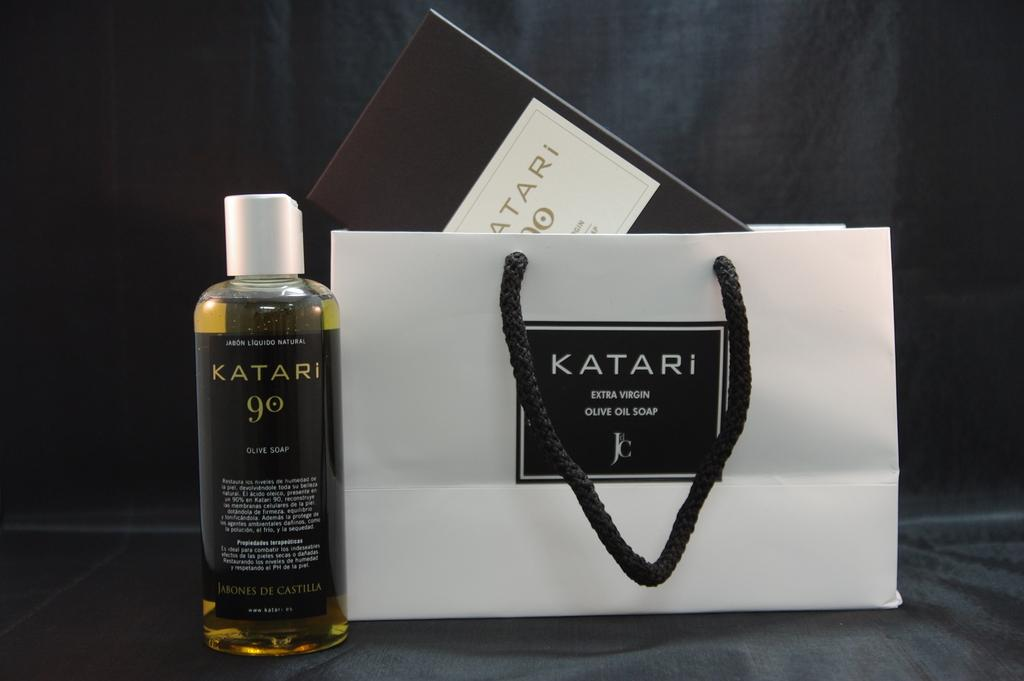Provide a one-sentence caption for the provided image. A bottle with the word Katari written in gold on in sits next to a bag with the same logo. 